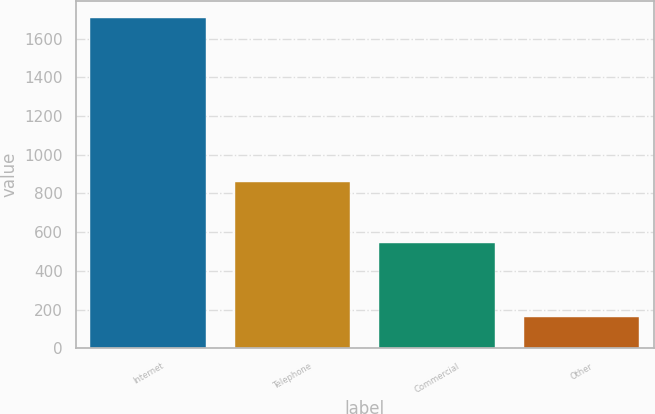Convert chart. <chart><loc_0><loc_0><loc_500><loc_500><bar_chart><fcel>Internet<fcel>Telephone<fcel>Commercial<fcel>Other<nl><fcel>1708<fcel>858<fcel>544<fcel>163<nl></chart> 